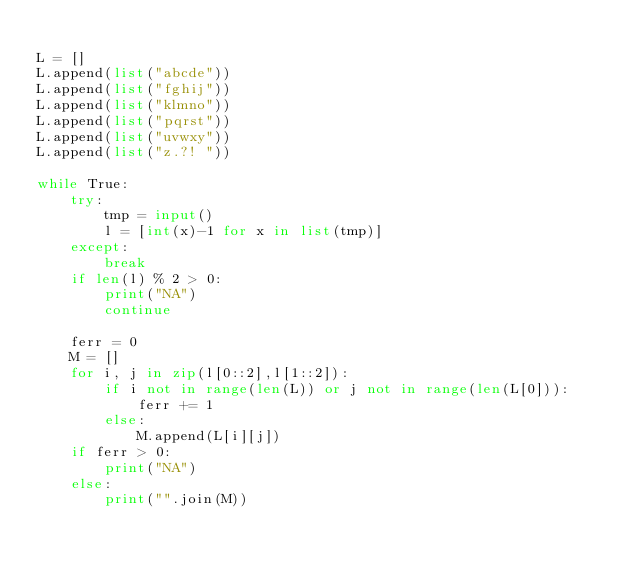<code> <loc_0><loc_0><loc_500><loc_500><_Python_>
L = []
L.append(list("abcde"))
L.append(list("fghij"))
L.append(list("klmno"))
L.append(list("pqrst"))
L.append(list("uvwxy"))
L.append(list("z.?! "))

while True:
    try:
        tmp = input()
        l = [int(x)-1 for x in list(tmp)]
    except:
        break
    if len(l) % 2 > 0:
        print("NA")
        continue

    ferr = 0
    M = []
    for i, j in zip(l[0::2],l[1::2]):
        if i not in range(len(L)) or j not in range(len(L[0])):
            ferr += 1
        else:
            M.append(L[i][j])
    if ferr > 0:
        print("NA")
    else:
        print("".join(M))


</code> 